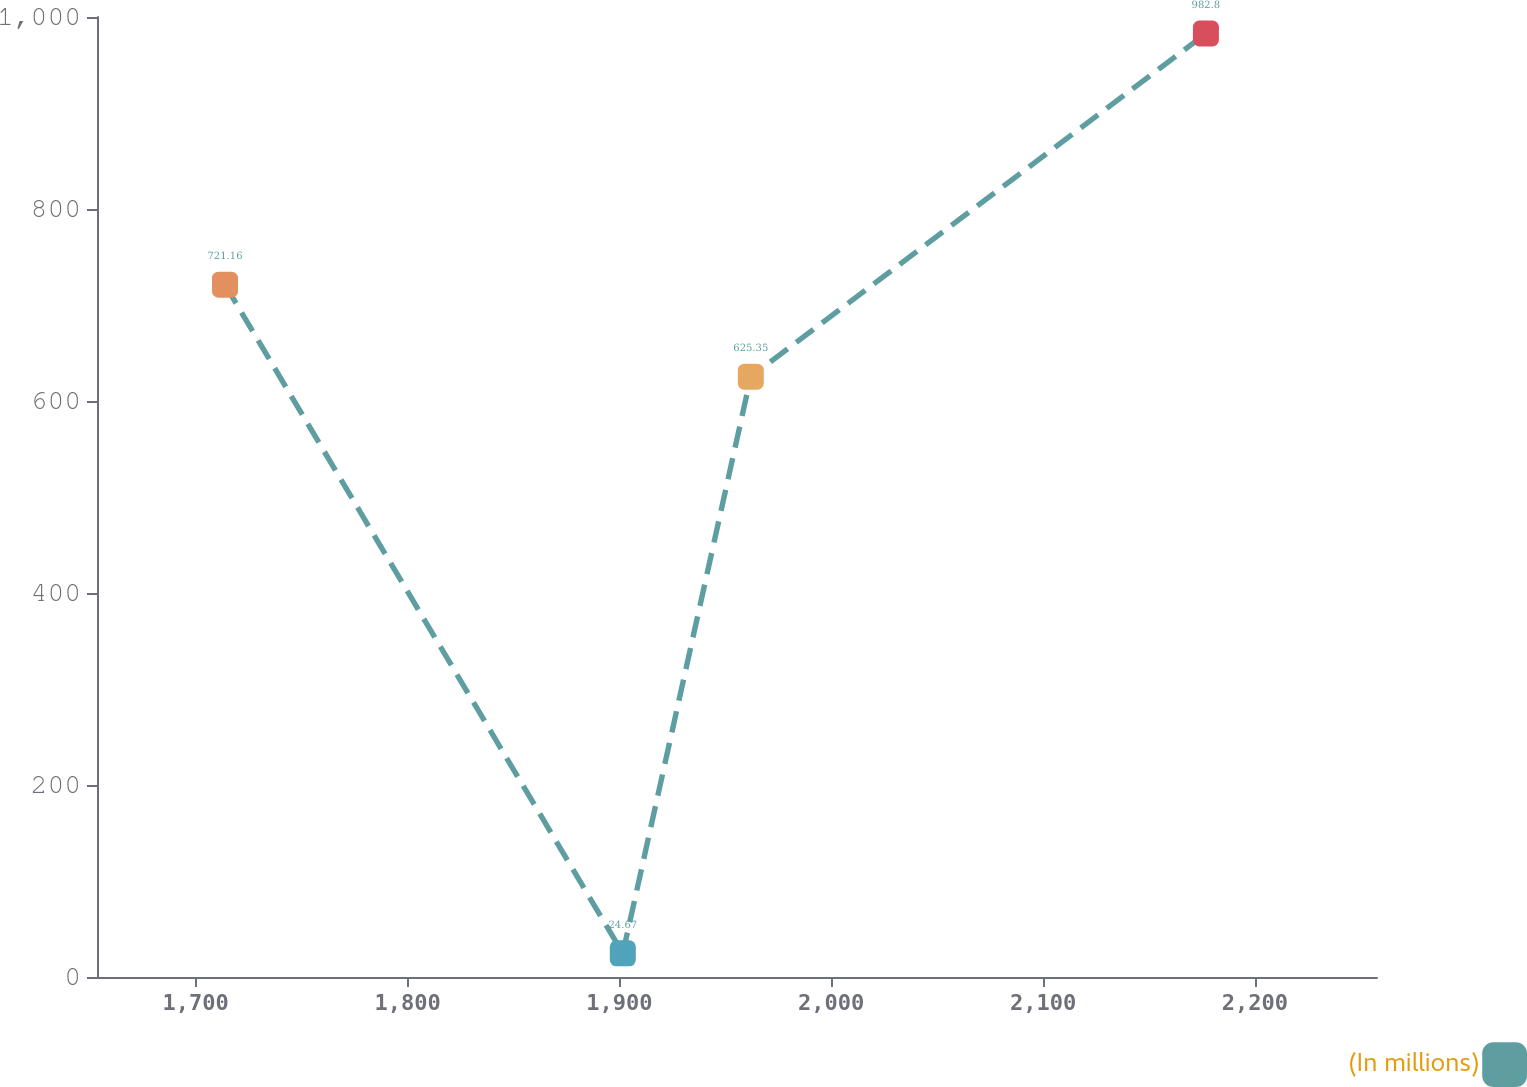Convert chart to OTSL. <chart><loc_0><loc_0><loc_500><loc_500><line_chart><ecel><fcel>(In millions)<nl><fcel>1713.84<fcel>721.16<nl><fcel>1901.62<fcel>24.67<nl><fcel>1962.04<fcel>625.35<nl><fcel>2176.87<fcel>982.8<nl><fcel>2318.05<fcel>529.54<nl></chart> 